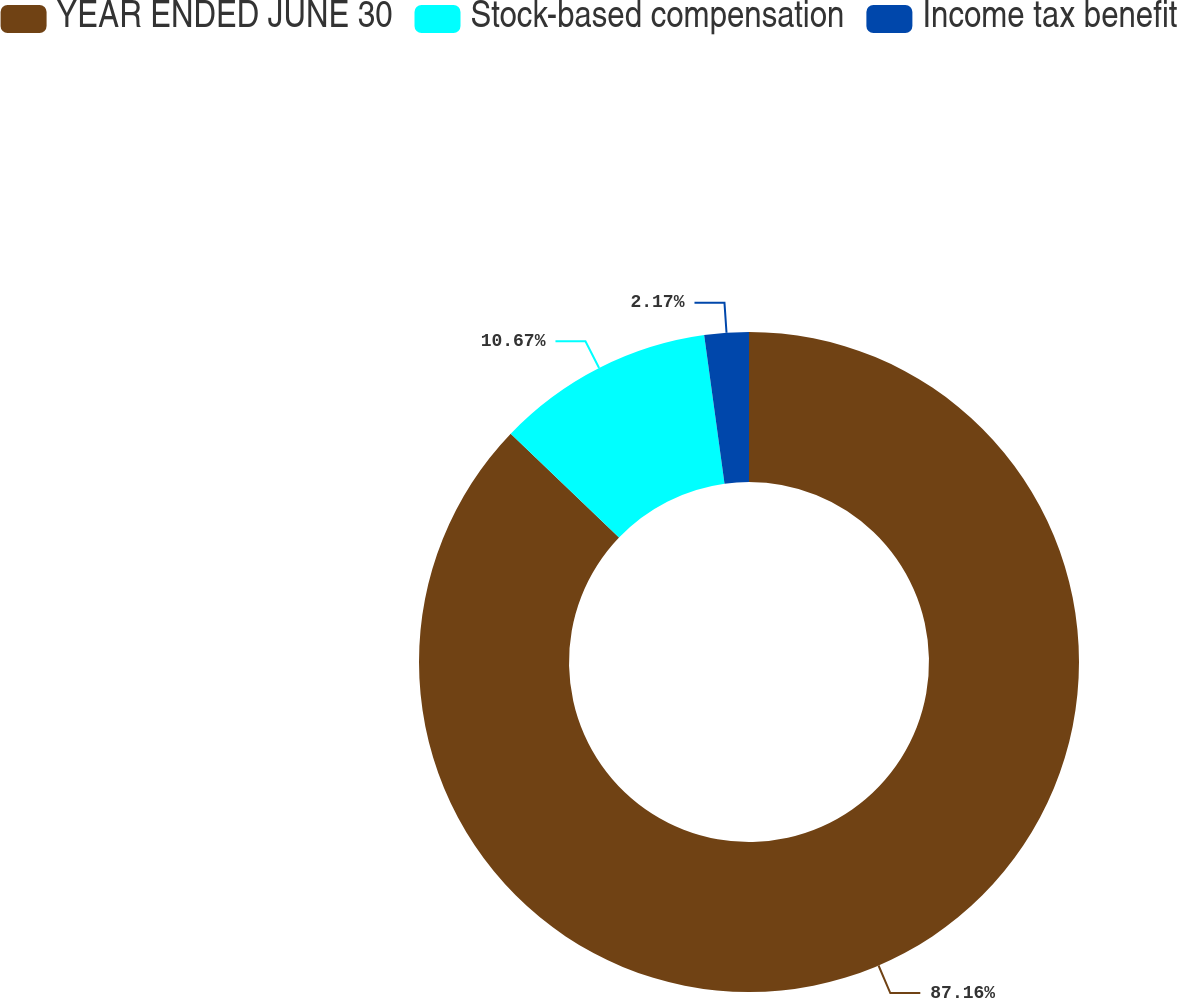Convert chart to OTSL. <chart><loc_0><loc_0><loc_500><loc_500><pie_chart><fcel>YEAR ENDED JUNE 30<fcel>Stock-based compensation<fcel>Income tax benefit<nl><fcel>87.16%<fcel>10.67%<fcel>2.17%<nl></chart> 